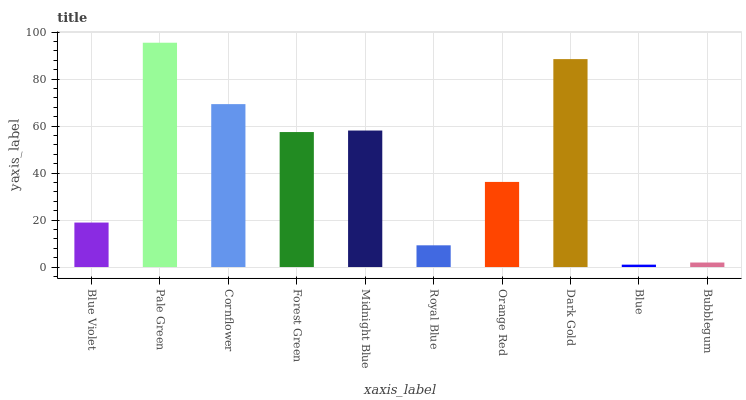Is Cornflower the minimum?
Answer yes or no. No. Is Cornflower the maximum?
Answer yes or no. No. Is Pale Green greater than Cornflower?
Answer yes or no. Yes. Is Cornflower less than Pale Green?
Answer yes or no. Yes. Is Cornflower greater than Pale Green?
Answer yes or no. No. Is Pale Green less than Cornflower?
Answer yes or no. No. Is Forest Green the high median?
Answer yes or no. Yes. Is Orange Red the low median?
Answer yes or no. Yes. Is Orange Red the high median?
Answer yes or no. No. Is Forest Green the low median?
Answer yes or no. No. 